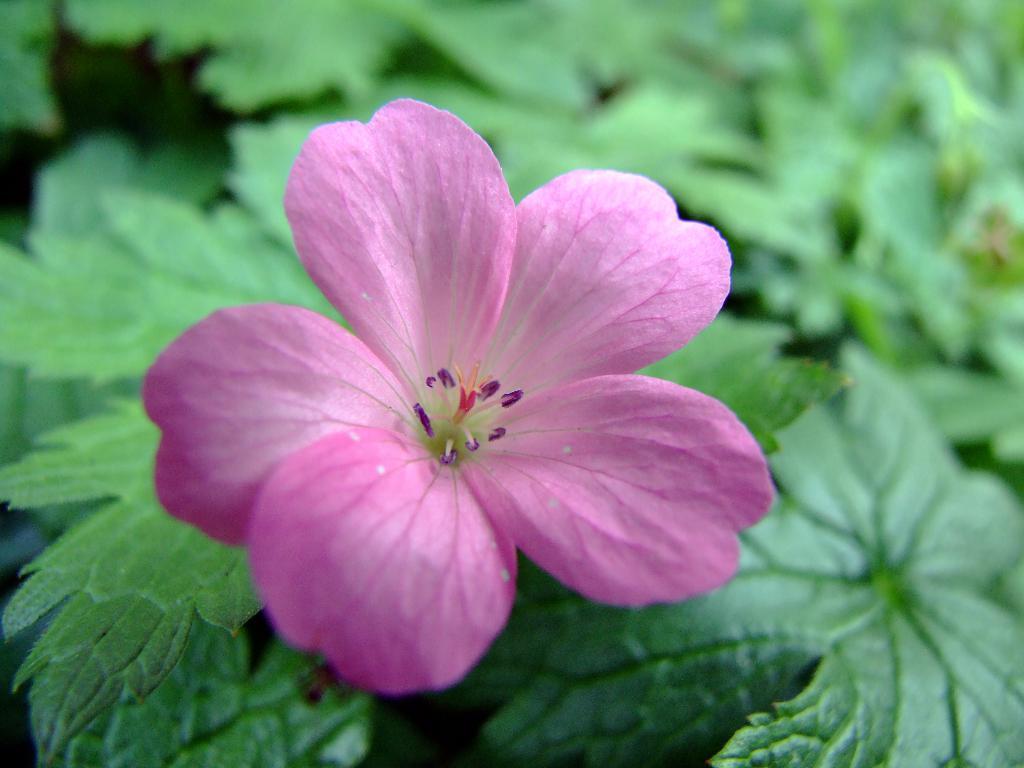Can you describe this image briefly? In the foreground of the image there is a flower. In the background of the image there are plants. 